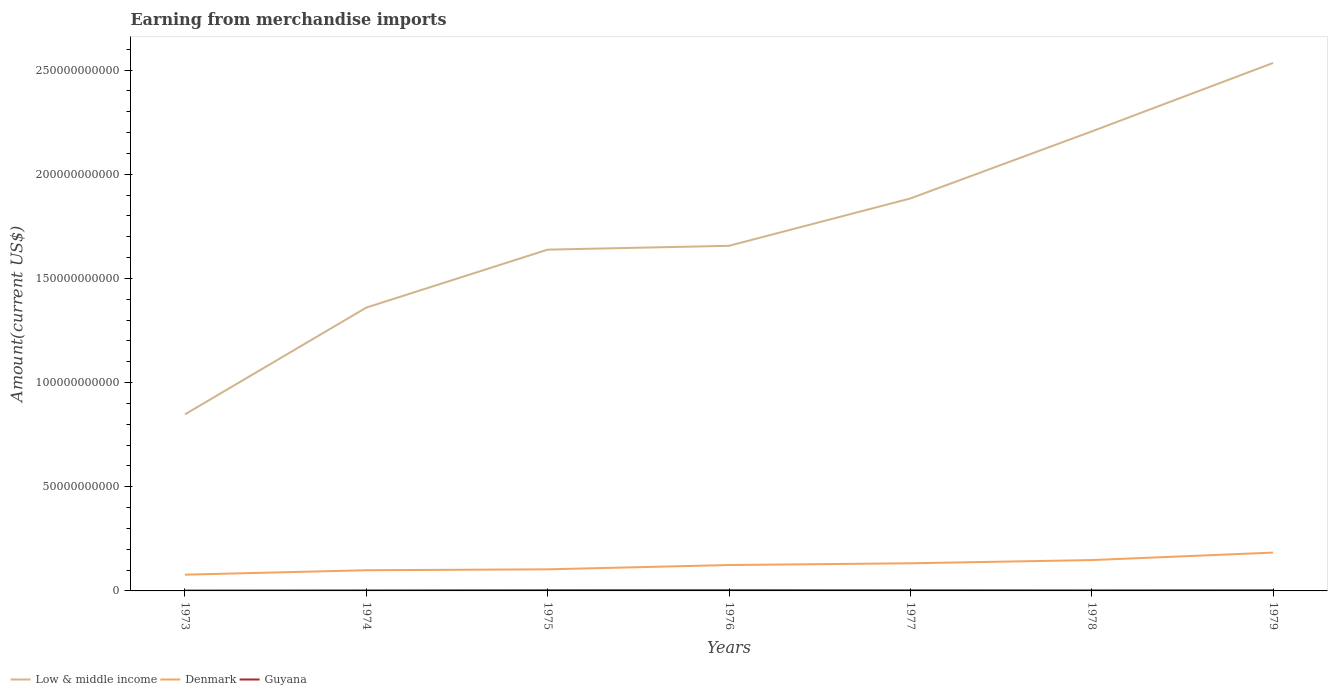How many different coloured lines are there?
Your answer should be very brief. 3. Across all years, what is the maximum amount earned from merchandise imports in Low & middle income?
Your answer should be very brief. 8.48e+1. In which year was the amount earned from merchandise imports in Low & middle income maximum?
Provide a short and direct response. 1973. What is the total amount earned from merchandise imports in Low & middle income in the graph?
Give a very brief answer. -5.68e+1. What is the difference between the highest and the second highest amount earned from merchandise imports in Low & middle income?
Keep it short and to the point. 1.69e+11. What is the difference between the highest and the lowest amount earned from merchandise imports in Guyana?
Offer a terse response. 4. Is the amount earned from merchandise imports in Denmark strictly greater than the amount earned from merchandise imports in Guyana over the years?
Your answer should be compact. No. How many lines are there?
Make the answer very short. 3. Are the values on the major ticks of Y-axis written in scientific E-notation?
Keep it short and to the point. No. Does the graph contain any zero values?
Provide a succinct answer. No. Does the graph contain grids?
Give a very brief answer. No. How many legend labels are there?
Keep it short and to the point. 3. What is the title of the graph?
Ensure brevity in your answer.  Earning from merchandise imports. What is the label or title of the Y-axis?
Your response must be concise. Amount(current US$). What is the Amount(current US$) of Low & middle income in 1973?
Your answer should be very brief. 8.48e+1. What is the Amount(current US$) in Denmark in 1973?
Your answer should be very brief. 7.80e+09. What is the Amount(current US$) of Guyana in 1973?
Offer a very short reply. 1.77e+08. What is the Amount(current US$) of Low & middle income in 1974?
Your response must be concise. 1.36e+11. What is the Amount(current US$) of Denmark in 1974?
Provide a succinct answer. 9.93e+09. What is the Amount(current US$) in Guyana in 1974?
Keep it short and to the point. 2.55e+08. What is the Amount(current US$) in Low & middle income in 1975?
Your answer should be compact. 1.64e+11. What is the Amount(current US$) in Denmark in 1975?
Give a very brief answer. 1.04e+1. What is the Amount(current US$) of Guyana in 1975?
Ensure brevity in your answer.  3.44e+08. What is the Amount(current US$) in Low & middle income in 1976?
Ensure brevity in your answer.  1.66e+11. What is the Amount(current US$) in Denmark in 1976?
Your response must be concise. 1.24e+1. What is the Amount(current US$) of Guyana in 1976?
Your answer should be very brief. 3.64e+08. What is the Amount(current US$) in Low & middle income in 1977?
Ensure brevity in your answer.  1.88e+11. What is the Amount(current US$) in Denmark in 1977?
Make the answer very short. 1.33e+1. What is the Amount(current US$) of Guyana in 1977?
Keep it short and to the point. 3.14e+08. What is the Amount(current US$) of Low & middle income in 1978?
Make the answer very short. 2.21e+11. What is the Amount(current US$) in Denmark in 1978?
Keep it short and to the point. 1.48e+1. What is the Amount(current US$) in Guyana in 1978?
Ensure brevity in your answer.  2.79e+08. What is the Amount(current US$) of Low & middle income in 1979?
Your answer should be compact. 2.53e+11. What is the Amount(current US$) of Denmark in 1979?
Your answer should be very brief. 1.84e+1. What is the Amount(current US$) of Guyana in 1979?
Provide a succinct answer. 3.18e+08. Across all years, what is the maximum Amount(current US$) of Low & middle income?
Offer a very short reply. 2.53e+11. Across all years, what is the maximum Amount(current US$) of Denmark?
Provide a succinct answer. 1.84e+1. Across all years, what is the maximum Amount(current US$) of Guyana?
Keep it short and to the point. 3.64e+08. Across all years, what is the minimum Amount(current US$) of Low & middle income?
Your response must be concise. 8.48e+1. Across all years, what is the minimum Amount(current US$) of Denmark?
Your answer should be compact. 7.80e+09. Across all years, what is the minimum Amount(current US$) of Guyana?
Offer a very short reply. 1.77e+08. What is the total Amount(current US$) in Low & middle income in the graph?
Your response must be concise. 1.21e+12. What is the total Amount(current US$) of Denmark in the graph?
Your answer should be very brief. 8.70e+1. What is the total Amount(current US$) of Guyana in the graph?
Give a very brief answer. 2.05e+09. What is the difference between the Amount(current US$) of Low & middle income in 1973 and that in 1974?
Keep it short and to the point. -5.12e+1. What is the difference between the Amount(current US$) of Denmark in 1973 and that in 1974?
Ensure brevity in your answer.  -2.12e+09. What is the difference between the Amount(current US$) in Guyana in 1973 and that in 1974?
Provide a short and direct response. -7.80e+07. What is the difference between the Amount(current US$) of Low & middle income in 1973 and that in 1975?
Provide a short and direct response. -7.91e+1. What is the difference between the Amount(current US$) in Denmark in 1973 and that in 1975?
Offer a very short reply. -2.57e+09. What is the difference between the Amount(current US$) in Guyana in 1973 and that in 1975?
Offer a very short reply. -1.67e+08. What is the difference between the Amount(current US$) of Low & middle income in 1973 and that in 1976?
Offer a terse response. -8.09e+1. What is the difference between the Amount(current US$) of Denmark in 1973 and that in 1976?
Provide a succinct answer. -4.62e+09. What is the difference between the Amount(current US$) of Guyana in 1973 and that in 1976?
Make the answer very short. -1.87e+08. What is the difference between the Amount(current US$) of Low & middle income in 1973 and that in 1977?
Provide a short and direct response. -1.04e+11. What is the difference between the Amount(current US$) of Denmark in 1973 and that in 1977?
Provide a short and direct response. -5.46e+09. What is the difference between the Amount(current US$) of Guyana in 1973 and that in 1977?
Keep it short and to the point. -1.37e+08. What is the difference between the Amount(current US$) in Low & middle income in 1973 and that in 1978?
Offer a terse response. -1.36e+11. What is the difference between the Amount(current US$) of Denmark in 1973 and that in 1978?
Your answer should be very brief. -7.01e+09. What is the difference between the Amount(current US$) in Guyana in 1973 and that in 1978?
Provide a succinct answer. -1.02e+08. What is the difference between the Amount(current US$) in Low & middle income in 1973 and that in 1979?
Provide a short and direct response. -1.69e+11. What is the difference between the Amount(current US$) of Denmark in 1973 and that in 1979?
Your answer should be very brief. -1.06e+1. What is the difference between the Amount(current US$) in Guyana in 1973 and that in 1979?
Your response must be concise. -1.41e+08. What is the difference between the Amount(current US$) in Low & middle income in 1974 and that in 1975?
Your answer should be very brief. -2.78e+1. What is the difference between the Amount(current US$) of Denmark in 1974 and that in 1975?
Offer a very short reply. -4.42e+08. What is the difference between the Amount(current US$) of Guyana in 1974 and that in 1975?
Make the answer very short. -8.89e+07. What is the difference between the Amount(current US$) of Low & middle income in 1974 and that in 1976?
Your answer should be compact. -2.97e+1. What is the difference between the Amount(current US$) in Denmark in 1974 and that in 1976?
Your answer should be compact. -2.50e+09. What is the difference between the Amount(current US$) of Guyana in 1974 and that in 1976?
Give a very brief answer. -1.09e+08. What is the difference between the Amount(current US$) of Low & middle income in 1974 and that in 1977?
Provide a succinct answer. -5.24e+1. What is the difference between the Amount(current US$) of Denmark in 1974 and that in 1977?
Your answer should be compact. -3.34e+09. What is the difference between the Amount(current US$) of Guyana in 1974 and that in 1977?
Provide a short and direct response. -5.88e+07. What is the difference between the Amount(current US$) of Low & middle income in 1974 and that in 1978?
Your answer should be compact. -8.46e+1. What is the difference between the Amount(current US$) of Denmark in 1974 and that in 1978?
Your answer should be very brief. -4.88e+09. What is the difference between the Amount(current US$) of Guyana in 1974 and that in 1978?
Make the answer very short. -2.39e+07. What is the difference between the Amount(current US$) of Low & middle income in 1974 and that in 1979?
Give a very brief answer. -1.17e+11. What is the difference between the Amount(current US$) in Denmark in 1974 and that in 1979?
Ensure brevity in your answer.  -8.47e+09. What is the difference between the Amount(current US$) of Guyana in 1974 and that in 1979?
Your answer should be very brief. -6.26e+07. What is the difference between the Amount(current US$) in Low & middle income in 1975 and that in 1976?
Your answer should be very brief. -1.84e+09. What is the difference between the Amount(current US$) in Denmark in 1975 and that in 1976?
Your answer should be compact. -2.06e+09. What is the difference between the Amount(current US$) in Guyana in 1975 and that in 1976?
Give a very brief answer. -1.98e+07. What is the difference between the Amount(current US$) in Low & middle income in 1975 and that in 1977?
Offer a very short reply. -2.46e+1. What is the difference between the Amount(current US$) in Denmark in 1975 and that in 1977?
Offer a terse response. -2.90e+09. What is the difference between the Amount(current US$) of Guyana in 1975 and that in 1977?
Give a very brief answer. 3.01e+07. What is the difference between the Amount(current US$) in Low & middle income in 1975 and that in 1978?
Ensure brevity in your answer.  -5.68e+1. What is the difference between the Amount(current US$) in Denmark in 1975 and that in 1978?
Your answer should be compact. -4.44e+09. What is the difference between the Amount(current US$) of Guyana in 1975 and that in 1978?
Give a very brief answer. 6.51e+07. What is the difference between the Amount(current US$) in Low & middle income in 1975 and that in 1979?
Keep it short and to the point. -8.96e+1. What is the difference between the Amount(current US$) of Denmark in 1975 and that in 1979?
Offer a terse response. -8.03e+09. What is the difference between the Amount(current US$) in Guyana in 1975 and that in 1979?
Your answer should be compact. 2.64e+07. What is the difference between the Amount(current US$) in Low & middle income in 1976 and that in 1977?
Provide a short and direct response. -2.27e+1. What is the difference between the Amount(current US$) in Denmark in 1976 and that in 1977?
Give a very brief answer. -8.38e+08. What is the difference between the Amount(current US$) of Guyana in 1976 and that in 1977?
Your answer should be very brief. 4.98e+07. What is the difference between the Amount(current US$) in Low & middle income in 1976 and that in 1978?
Offer a terse response. -5.49e+1. What is the difference between the Amount(current US$) of Denmark in 1976 and that in 1978?
Make the answer very short. -2.38e+09. What is the difference between the Amount(current US$) in Guyana in 1976 and that in 1978?
Keep it short and to the point. 8.48e+07. What is the difference between the Amount(current US$) in Low & middle income in 1976 and that in 1979?
Provide a succinct answer. -8.78e+1. What is the difference between the Amount(current US$) of Denmark in 1976 and that in 1979?
Your response must be concise. -5.97e+09. What is the difference between the Amount(current US$) of Guyana in 1976 and that in 1979?
Your answer should be very brief. 4.61e+07. What is the difference between the Amount(current US$) of Low & middle income in 1977 and that in 1978?
Your response must be concise. -3.22e+1. What is the difference between the Amount(current US$) of Denmark in 1977 and that in 1978?
Make the answer very short. -1.54e+09. What is the difference between the Amount(current US$) of Guyana in 1977 and that in 1978?
Give a very brief answer. 3.50e+07. What is the difference between the Amount(current US$) of Low & middle income in 1977 and that in 1979?
Your answer should be very brief. -6.50e+1. What is the difference between the Amount(current US$) in Denmark in 1977 and that in 1979?
Offer a terse response. -5.14e+09. What is the difference between the Amount(current US$) of Guyana in 1977 and that in 1979?
Keep it short and to the point. -3.73e+06. What is the difference between the Amount(current US$) in Low & middle income in 1978 and that in 1979?
Provide a succinct answer. -3.29e+1. What is the difference between the Amount(current US$) of Denmark in 1978 and that in 1979?
Keep it short and to the point. -3.59e+09. What is the difference between the Amount(current US$) in Guyana in 1978 and that in 1979?
Give a very brief answer. -3.87e+07. What is the difference between the Amount(current US$) in Low & middle income in 1973 and the Amount(current US$) in Denmark in 1974?
Keep it short and to the point. 7.48e+1. What is the difference between the Amount(current US$) in Low & middle income in 1973 and the Amount(current US$) in Guyana in 1974?
Make the answer very short. 8.45e+1. What is the difference between the Amount(current US$) in Denmark in 1973 and the Amount(current US$) in Guyana in 1974?
Ensure brevity in your answer.  7.55e+09. What is the difference between the Amount(current US$) of Low & middle income in 1973 and the Amount(current US$) of Denmark in 1975?
Offer a terse response. 7.44e+1. What is the difference between the Amount(current US$) in Low & middle income in 1973 and the Amount(current US$) in Guyana in 1975?
Your answer should be compact. 8.44e+1. What is the difference between the Amount(current US$) of Denmark in 1973 and the Amount(current US$) of Guyana in 1975?
Give a very brief answer. 7.46e+09. What is the difference between the Amount(current US$) in Low & middle income in 1973 and the Amount(current US$) in Denmark in 1976?
Keep it short and to the point. 7.23e+1. What is the difference between the Amount(current US$) of Low & middle income in 1973 and the Amount(current US$) of Guyana in 1976?
Make the answer very short. 8.44e+1. What is the difference between the Amount(current US$) of Denmark in 1973 and the Amount(current US$) of Guyana in 1976?
Your answer should be compact. 7.44e+09. What is the difference between the Amount(current US$) of Low & middle income in 1973 and the Amount(current US$) of Denmark in 1977?
Make the answer very short. 7.15e+1. What is the difference between the Amount(current US$) in Low & middle income in 1973 and the Amount(current US$) in Guyana in 1977?
Your answer should be very brief. 8.44e+1. What is the difference between the Amount(current US$) of Denmark in 1973 and the Amount(current US$) of Guyana in 1977?
Keep it short and to the point. 7.49e+09. What is the difference between the Amount(current US$) in Low & middle income in 1973 and the Amount(current US$) in Denmark in 1978?
Ensure brevity in your answer.  6.99e+1. What is the difference between the Amount(current US$) of Low & middle income in 1973 and the Amount(current US$) of Guyana in 1978?
Ensure brevity in your answer.  8.45e+1. What is the difference between the Amount(current US$) in Denmark in 1973 and the Amount(current US$) in Guyana in 1978?
Offer a very short reply. 7.52e+09. What is the difference between the Amount(current US$) in Low & middle income in 1973 and the Amount(current US$) in Denmark in 1979?
Your answer should be compact. 6.64e+1. What is the difference between the Amount(current US$) in Low & middle income in 1973 and the Amount(current US$) in Guyana in 1979?
Your answer should be very brief. 8.44e+1. What is the difference between the Amount(current US$) in Denmark in 1973 and the Amount(current US$) in Guyana in 1979?
Make the answer very short. 7.48e+09. What is the difference between the Amount(current US$) of Low & middle income in 1974 and the Amount(current US$) of Denmark in 1975?
Provide a short and direct response. 1.26e+11. What is the difference between the Amount(current US$) in Low & middle income in 1974 and the Amount(current US$) in Guyana in 1975?
Keep it short and to the point. 1.36e+11. What is the difference between the Amount(current US$) of Denmark in 1974 and the Amount(current US$) of Guyana in 1975?
Your response must be concise. 9.58e+09. What is the difference between the Amount(current US$) of Low & middle income in 1974 and the Amount(current US$) of Denmark in 1976?
Ensure brevity in your answer.  1.24e+11. What is the difference between the Amount(current US$) in Low & middle income in 1974 and the Amount(current US$) in Guyana in 1976?
Provide a short and direct response. 1.36e+11. What is the difference between the Amount(current US$) in Denmark in 1974 and the Amount(current US$) in Guyana in 1976?
Your answer should be compact. 9.56e+09. What is the difference between the Amount(current US$) in Low & middle income in 1974 and the Amount(current US$) in Denmark in 1977?
Provide a succinct answer. 1.23e+11. What is the difference between the Amount(current US$) of Low & middle income in 1974 and the Amount(current US$) of Guyana in 1977?
Your response must be concise. 1.36e+11. What is the difference between the Amount(current US$) in Denmark in 1974 and the Amount(current US$) in Guyana in 1977?
Provide a succinct answer. 9.61e+09. What is the difference between the Amount(current US$) of Low & middle income in 1974 and the Amount(current US$) of Denmark in 1978?
Ensure brevity in your answer.  1.21e+11. What is the difference between the Amount(current US$) in Low & middle income in 1974 and the Amount(current US$) in Guyana in 1978?
Provide a succinct answer. 1.36e+11. What is the difference between the Amount(current US$) in Denmark in 1974 and the Amount(current US$) in Guyana in 1978?
Ensure brevity in your answer.  9.65e+09. What is the difference between the Amount(current US$) in Low & middle income in 1974 and the Amount(current US$) in Denmark in 1979?
Ensure brevity in your answer.  1.18e+11. What is the difference between the Amount(current US$) in Low & middle income in 1974 and the Amount(current US$) in Guyana in 1979?
Your answer should be compact. 1.36e+11. What is the difference between the Amount(current US$) of Denmark in 1974 and the Amount(current US$) of Guyana in 1979?
Provide a short and direct response. 9.61e+09. What is the difference between the Amount(current US$) of Low & middle income in 1975 and the Amount(current US$) of Denmark in 1976?
Provide a succinct answer. 1.51e+11. What is the difference between the Amount(current US$) of Low & middle income in 1975 and the Amount(current US$) of Guyana in 1976?
Your answer should be very brief. 1.63e+11. What is the difference between the Amount(current US$) in Denmark in 1975 and the Amount(current US$) in Guyana in 1976?
Your answer should be compact. 1.00e+1. What is the difference between the Amount(current US$) in Low & middle income in 1975 and the Amount(current US$) in Denmark in 1977?
Provide a short and direct response. 1.51e+11. What is the difference between the Amount(current US$) in Low & middle income in 1975 and the Amount(current US$) in Guyana in 1977?
Ensure brevity in your answer.  1.64e+11. What is the difference between the Amount(current US$) in Denmark in 1975 and the Amount(current US$) in Guyana in 1977?
Make the answer very short. 1.01e+1. What is the difference between the Amount(current US$) of Low & middle income in 1975 and the Amount(current US$) of Denmark in 1978?
Your response must be concise. 1.49e+11. What is the difference between the Amount(current US$) of Low & middle income in 1975 and the Amount(current US$) of Guyana in 1978?
Provide a succinct answer. 1.64e+11. What is the difference between the Amount(current US$) in Denmark in 1975 and the Amount(current US$) in Guyana in 1978?
Give a very brief answer. 1.01e+1. What is the difference between the Amount(current US$) in Low & middle income in 1975 and the Amount(current US$) in Denmark in 1979?
Provide a short and direct response. 1.45e+11. What is the difference between the Amount(current US$) in Low & middle income in 1975 and the Amount(current US$) in Guyana in 1979?
Offer a very short reply. 1.64e+11. What is the difference between the Amount(current US$) in Denmark in 1975 and the Amount(current US$) in Guyana in 1979?
Your answer should be very brief. 1.01e+1. What is the difference between the Amount(current US$) of Low & middle income in 1976 and the Amount(current US$) of Denmark in 1977?
Ensure brevity in your answer.  1.52e+11. What is the difference between the Amount(current US$) of Low & middle income in 1976 and the Amount(current US$) of Guyana in 1977?
Provide a short and direct response. 1.65e+11. What is the difference between the Amount(current US$) of Denmark in 1976 and the Amount(current US$) of Guyana in 1977?
Give a very brief answer. 1.21e+1. What is the difference between the Amount(current US$) in Low & middle income in 1976 and the Amount(current US$) in Denmark in 1978?
Provide a succinct answer. 1.51e+11. What is the difference between the Amount(current US$) in Low & middle income in 1976 and the Amount(current US$) in Guyana in 1978?
Your response must be concise. 1.65e+11. What is the difference between the Amount(current US$) in Denmark in 1976 and the Amount(current US$) in Guyana in 1978?
Your answer should be very brief. 1.21e+1. What is the difference between the Amount(current US$) in Low & middle income in 1976 and the Amount(current US$) in Denmark in 1979?
Your response must be concise. 1.47e+11. What is the difference between the Amount(current US$) of Low & middle income in 1976 and the Amount(current US$) of Guyana in 1979?
Your response must be concise. 1.65e+11. What is the difference between the Amount(current US$) in Denmark in 1976 and the Amount(current US$) in Guyana in 1979?
Offer a terse response. 1.21e+1. What is the difference between the Amount(current US$) in Low & middle income in 1977 and the Amount(current US$) in Denmark in 1978?
Make the answer very short. 1.74e+11. What is the difference between the Amount(current US$) in Low & middle income in 1977 and the Amount(current US$) in Guyana in 1978?
Ensure brevity in your answer.  1.88e+11. What is the difference between the Amount(current US$) in Denmark in 1977 and the Amount(current US$) in Guyana in 1978?
Offer a very short reply. 1.30e+1. What is the difference between the Amount(current US$) of Low & middle income in 1977 and the Amount(current US$) of Denmark in 1979?
Keep it short and to the point. 1.70e+11. What is the difference between the Amount(current US$) in Low & middle income in 1977 and the Amount(current US$) in Guyana in 1979?
Offer a terse response. 1.88e+11. What is the difference between the Amount(current US$) of Denmark in 1977 and the Amount(current US$) of Guyana in 1979?
Your response must be concise. 1.29e+1. What is the difference between the Amount(current US$) in Low & middle income in 1978 and the Amount(current US$) in Denmark in 1979?
Your answer should be compact. 2.02e+11. What is the difference between the Amount(current US$) in Low & middle income in 1978 and the Amount(current US$) in Guyana in 1979?
Ensure brevity in your answer.  2.20e+11. What is the difference between the Amount(current US$) of Denmark in 1978 and the Amount(current US$) of Guyana in 1979?
Ensure brevity in your answer.  1.45e+1. What is the average Amount(current US$) of Low & middle income per year?
Your answer should be compact. 1.73e+11. What is the average Amount(current US$) in Denmark per year?
Your response must be concise. 1.24e+1. What is the average Amount(current US$) in Guyana per year?
Provide a short and direct response. 2.93e+08. In the year 1973, what is the difference between the Amount(current US$) of Low & middle income and Amount(current US$) of Denmark?
Make the answer very short. 7.70e+1. In the year 1973, what is the difference between the Amount(current US$) of Low & middle income and Amount(current US$) of Guyana?
Offer a very short reply. 8.46e+1. In the year 1973, what is the difference between the Amount(current US$) of Denmark and Amount(current US$) of Guyana?
Give a very brief answer. 7.62e+09. In the year 1974, what is the difference between the Amount(current US$) of Low & middle income and Amount(current US$) of Denmark?
Your answer should be very brief. 1.26e+11. In the year 1974, what is the difference between the Amount(current US$) of Low & middle income and Amount(current US$) of Guyana?
Keep it short and to the point. 1.36e+11. In the year 1974, what is the difference between the Amount(current US$) of Denmark and Amount(current US$) of Guyana?
Your response must be concise. 9.67e+09. In the year 1975, what is the difference between the Amount(current US$) of Low & middle income and Amount(current US$) of Denmark?
Ensure brevity in your answer.  1.53e+11. In the year 1975, what is the difference between the Amount(current US$) of Low & middle income and Amount(current US$) of Guyana?
Ensure brevity in your answer.  1.63e+11. In the year 1975, what is the difference between the Amount(current US$) in Denmark and Amount(current US$) in Guyana?
Make the answer very short. 1.00e+1. In the year 1976, what is the difference between the Amount(current US$) of Low & middle income and Amount(current US$) of Denmark?
Offer a very short reply. 1.53e+11. In the year 1976, what is the difference between the Amount(current US$) in Low & middle income and Amount(current US$) in Guyana?
Ensure brevity in your answer.  1.65e+11. In the year 1976, what is the difference between the Amount(current US$) of Denmark and Amount(current US$) of Guyana?
Your answer should be compact. 1.21e+1. In the year 1977, what is the difference between the Amount(current US$) of Low & middle income and Amount(current US$) of Denmark?
Make the answer very short. 1.75e+11. In the year 1977, what is the difference between the Amount(current US$) in Low & middle income and Amount(current US$) in Guyana?
Provide a short and direct response. 1.88e+11. In the year 1977, what is the difference between the Amount(current US$) in Denmark and Amount(current US$) in Guyana?
Provide a short and direct response. 1.30e+1. In the year 1978, what is the difference between the Amount(current US$) of Low & middle income and Amount(current US$) of Denmark?
Make the answer very short. 2.06e+11. In the year 1978, what is the difference between the Amount(current US$) in Low & middle income and Amount(current US$) in Guyana?
Keep it short and to the point. 2.20e+11. In the year 1978, what is the difference between the Amount(current US$) of Denmark and Amount(current US$) of Guyana?
Give a very brief answer. 1.45e+1. In the year 1979, what is the difference between the Amount(current US$) in Low & middle income and Amount(current US$) in Denmark?
Ensure brevity in your answer.  2.35e+11. In the year 1979, what is the difference between the Amount(current US$) in Low & middle income and Amount(current US$) in Guyana?
Your answer should be very brief. 2.53e+11. In the year 1979, what is the difference between the Amount(current US$) of Denmark and Amount(current US$) of Guyana?
Provide a succinct answer. 1.81e+1. What is the ratio of the Amount(current US$) of Low & middle income in 1973 to that in 1974?
Your response must be concise. 0.62. What is the ratio of the Amount(current US$) in Denmark in 1973 to that in 1974?
Keep it short and to the point. 0.79. What is the ratio of the Amount(current US$) of Guyana in 1973 to that in 1974?
Offer a terse response. 0.69. What is the ratio of the Amount(current US$) of Low & middle income in 1973 to that in 1975?
Offer a terse response. 0.52. What is the ratio of the Amount(current US$) in Denmark in 1973 to that in 1975?
Give a very brief answer. 0.75. What is the ratio of the Amount(current US$) in Guyana in 1973 to that in 1975?
Ensure brevity in your answer.  0.51. What is the ratio of the Amount(current US$) of Low & middle income in 1973 to that in 1976?
Keep it short and to the point. 0.51. What is the ratio of the Amount(current US$) in Denmark in 1973 to that in 1976?
Keep it short and to the point. 0.63. What is the ratio of the Amount(current US$) in Guyana in 1973 to that in 1976?
Offer a very short reply. 0.49. What is the ratio of the Amount(current US$) of Low & middle income in 1973 to that in 1977?
Your answer should be compact. 0.45. What is the ratio of the Amount(current US$) in Denmark in 1973 to that in 1977?
Give a very brief answer. 0.59. What is the ratio of the Amount(current US$) of Guyana in 1973 to that in 1977?
Keep it short and to the point. 0.56. What is the ratio of the Amount(current US$) in Low & middle income in 1973 to that in 1978?
Your response must be concise. 0.38. What is the ratio of the Amount(current US$) in Denmark in 1973 to that in 1978?
Keep it short and to the point. 0.53. What is the ratio of the Amount(current US$) of Guyana in 1973 to that in 1978?
Make the answer very short. 0.63. What is the ratio of the Amount(current US$) in Low & middle income in 1973 to that in 1979?
Offer a terse response. 0.33. What is the ratio of the Amount(current US$) in Denmark in 1973 to that in 1979?
Provide a short and direct response. 0.42. What is the ratio of the Amount(current US$) of Guyana in 1973 to that in 1979?
Offer a terse response. 0.56. What is the ratio of the Amount(current US$) in Low & middle income in 1974 to that in 1975?
Provide a succinct answer. 0.83. What is the ratio of the Amount(current US$) in Denmark in 1974 to that in 1975?
Provide a short and direct response. 0.96. What is the ratio of the Amount(current US$) in Guyana in 1974 to that in 1975?
Provide a succinct answer. 0.74. What is the ratio of the Amount(current US$) of Low & middle income in 1974 to that in 1976?
Your response must be concise. 0.82. What is the ratio of the Amount(current US$) in Denmark in 1974 to that in 1976?
Your answer should be compact. 0.8. What is the ratio of the Amount(current US$) of Guyana in 1974 to that in 1976?
Your answer should be compact. 0.7. What is the ratio of the Amount(current US$) of Low & middle income in 1974 to that in 1977?
Ensure brevity in your answer.  0.72. What is the ratio of the Amount(current US$) in Denmark in 1974 to that in 1977?
Ensure brevity in your answer.  0.75. What is the ratio of the Amount(current US$) of Guyana in 1974 to that in 1977?
Your answer should be very brief. 0.81. What is the ratio of the Amount(current US$) of Low & middle income in 1974 to that in 1978?
Offer a very short reply. 0.62. What is the ratio of the Amount(current US$) of Denmark in 1974 to that in 1978?
Keep it short and to the point. 0.67. What is the ratio of the Amount(current US$) of Guyana in 1974 to that in 1978?
Your response must be concise. 0.91. What is the ratio of the Amount(current US$) of Low & middle income in 1974 to that in 1979?
Your answer should be very brief. 0.54. What is the ratio of the Amount(current US$) of Denmark in 1974 to that in 1979?
Your answer should be very brief. 0.54. What is the ratio of the Amount(current US$) of Guyana in 1974 to that in 1979?
Offer a very short reply. 0.8. What is the ratio of the Amount(current US$) of Low & middle income in 1975 to that in 1976?
Offer a terse response. 0.99. What is the ratio of the Amount(current US$) of Denmark in 1975 to that in 1976?
Your answer should be compact. 0.83. What is the ratio of the Amount(current US$) in Guyana in 1975 to that in 1976?
Your response must be concise. 0.95. What is the ratio of the Amount(current US$) in Low & middle income in 1975 to that in 1977?
Your response must be concise. 0.87. What is the ratio of the Amount(current US$) of Denmark in 1975 to that in 1977?
Offer a very short reply. 0.78. What is the ratio of the Amount(current US$) in Guyana in 1975 to that in 1977?
Give a very brief answer. 1.1. What is the ratio of the Amount(current US$) of Low & middle income in 1975 to that in 1978?
Offer a terse response. 0.74. What is the ratio of the Amount(current US$) of Denmark in 1975 to that in 1978?
Your answer should be compact. 0.7. What is the ratio of the Amount(current US$) of Guyana in 1975 to that in 1978?
Ensure brevity in your answer.  1.23. What is the ratio of the Amount(current US$) of Low & middle income in 1975 to that in 1979?
Offer a very short reply. 0.65. What is the ratio of the Amount(current US$) in Denmark in 1975 to that in 1979?
Provide a short and direct response. 0.56. What is the ratio of the Amount(current US$) in Guyana in 1975 to that in 1979?
Your answer should be very brief. 1.08. What is the ratio of the Amount(current US$) of Low & middle income in 1976 to that in 1977?
Your answer should be compact. 0.88. What is the ratio of the Amount(current US$) of Denmark in 1976 to that in 1977?
Keep it short and to the point. 0.94. What is the ratio of the Amount(current US$) in Guyana in 1976 to that in 1977?
Keep it short and to the point. 1.16. What is the ratio of the Amount(current US$) in Low & middle income in 1976 to that in 1978?
Make the answer very short. 0.75. What is the ratio of the Amount(current US$) in Denmark in 1976 to that in 1978?
Keep it short and to the point. 0.84. What is the ratio of the Amount(current US$) of Guyana in 1976 to that in 1978?
Ensure brevity in your answer.  1.3. What is the ratio of the Amount(current US$) of Low & middle income in 1976 to that in 1979?
Offer a very short reply. 0.65. What is the ratio of the Amount(current US$) in Denmark in 1976 to that in 1979?
Provide a succinct answer. 0.68. What is the ratio of the Amount(current US$) of Guyana in 1976 to that in 1979?
Your answer should be compact. 1.15. What is the ratio of the Amount(current US$) of Low & middle income in 1977 to that in 1978?
Ensure brevity in your answer.  0.85. What is the ratio of the Amount(current US$) in Denmark in 1977 to that in 1978?
Give a very brief answer. 0.9. What is the ratio of the Amount(current US$) of Guyana in 1977 to that in 1978?
Keep it short and to the point. 1.13. What is the ratio of the Amount(current US$) in Low & middle income in 1977 to that in 1979?
Your answer should be very brief. 0.74. What is the ratio of the Amount(current US$) in Denmark in 1977 to that in 1979?
Provide a short and direct response. 0.72. What is the ratio of the Amount(current US$) of Guyana in 1977 to that in 1979?
Give a very brief answer. 0.99. What is the ratio of the Amount(current US$) of Low & middle income in 1978 to that in 1979?
Give a very brief answer. 0.87. What is the ratio of the Amount(current US$) of Denmark in 1978 to that in 1979?
Ensure brevity in your answer.  0.8. What is the ratio of the Amount(current US$) of Guyana in 1978 to that in 1979?
Your answer should be compact. 0.88. What is the difference between the highest and the second highest Amount(current US$) in Low & middle income?
Ensure brevity in your answer.  3.29e+1. What is the difference between the highest and the second highest Amount(current US$) in Denmark?
Offer a terse response. 3.59e+09. What is the difference between the highest and the second highest Amount(current US$) in Guyana?
Offer a very short reply. 1.98e+07. What is the difference between the highest and the lowest Amount(current US$) of Low & middle income?
Provide a short and direct response. 1.69e+11. What is the difference between the highest and the lowest Amount(current US$) of Denmark?
Offer a very short reply. 1.06e+1. What is the difference between the highest and the lowest Amount(current US$) in Guyana?
Give a very brief answer. 1.87e+08. 